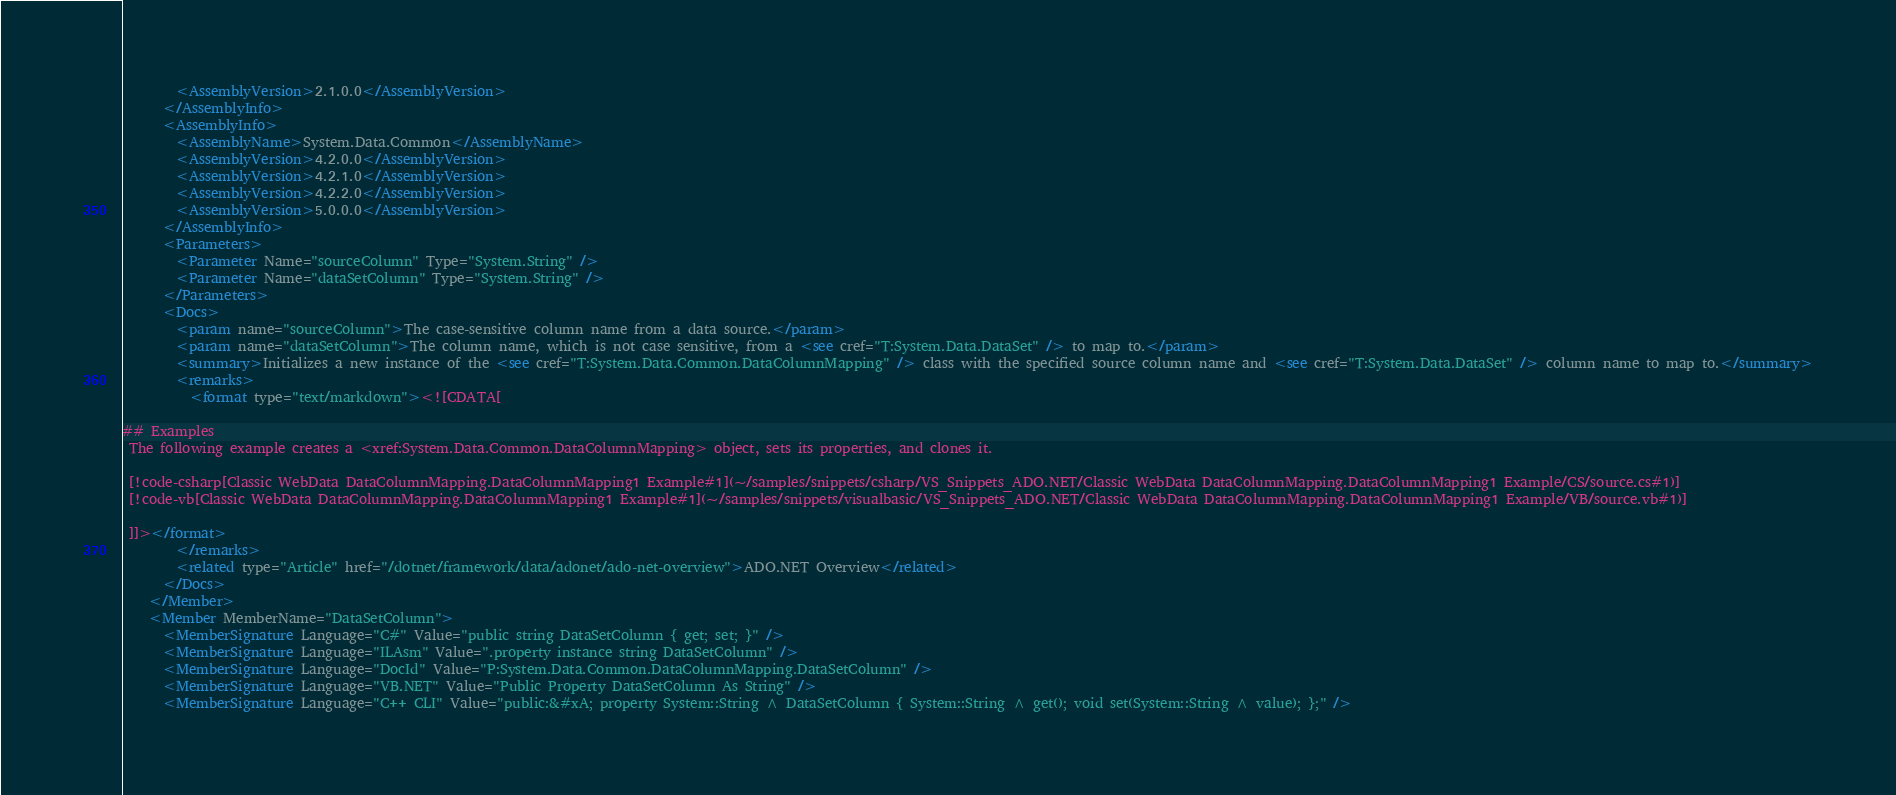<code> <loc_0><loc_0><loc_500><loc_500><_XML_>        <AssemblyVersion>2.1.0.0</AssemblyVersion>
      </AssemblyInfo>
      <AssemblyInfo>
        <AssemblyName>System.Data.Common</AssemblyName>
        <AssemblyVersion>4.2.0.0</AssemblyVersion>
        <AssemblyVersion>4.2.1.0</AssemblyVersion>
        <AssemblyVersion>4.2.2.0</AssemblyVersion>
        <AssemblyVersion>5.0.0.0</AssemblyVersion>
      </AssemblyInfo>
      <Parameters>
        <Parameter Name="sourceColumn" Type="System.String" />
        <Parameter Name="dataSetColumn" Type="System.String" />
      </Parameters>
      <Docs>
        <param name="sourceColumn">The case-sensitive column name from a data source.</param>
        <param name="dataSetColumn">The column name, which is not case sensitive, from a <see cref="T:System.Data.DataSet" /> to map to.</param>
        <summary>Initializes a new instance of the <see cref="T:System.Data.Common.DataColumnMapping" /> class with the specified source column name and <see cref="T:System.Data.DataSet" /> column name to map to.</summary>
        <remarks>
          <format type="text/markdown"><![CDATA[  
  
## Examples  
 The following example creates a <xref:System.Data.Common.DataColumnMapping> object, sets its properties, and clones it.  
  
 [!code-csharp[Classic WebData DataColumnMapping.DataColumnMapping1 Example#1](~/samples/snippets/csharp/VS_Snippets_ADO.NET/Classic WebData DataColumnMapping.DataColumnMapping1 Example/CS/source.cs#1)]
 [!code-vb[Classic WebData DataColumnMapping.DataColumnMapping1 Example#1](~/samples/snippets/visualbasic/VS_Snippets_ADO.NET/Classic WebData DataColumnMapping.DataColumnMapping1 Example/VB/source.vb#1)]  
  
 ]]></format>
        </remarks>
        <related type="Article" href="/dotnet/framework/data/adonet/ado-net-overview">ADO.NET Overview</related>
      </Docs>
    </Member>
    <Member MemberName="DataSetColumn">
      <MemberSignature Language="C#" Value="public string DataSetColumn { get; set; }" />
      <MemberSignature Language="ILAsm" Value=".property instance string DataSetColumn" />
      <MemberSignature Language="DocId" Value="P:System.Data.Common.DataColumnMapping.DataSetColumn" />
      <MemberSignature Language="VB.NET" Value="Public Property DataSetColumn As String" />
      <MemberSignature Language="C++ CLI" Value="public:&#xA; property System::String ^ DataSetColumn { System::String ^ get(); void set(System::String ^ value); };" /></code> 